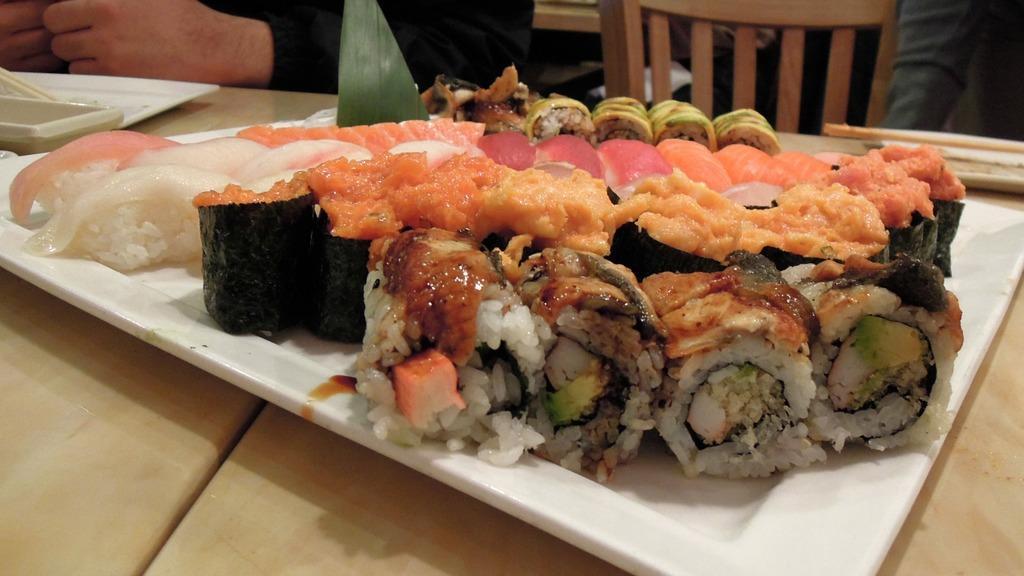Describe this image in one or two sentences. In this image I can see plates in which food items are kept on the table. In the background I can see a person is sitting on the chair. This image is taken may be in a hotel. 